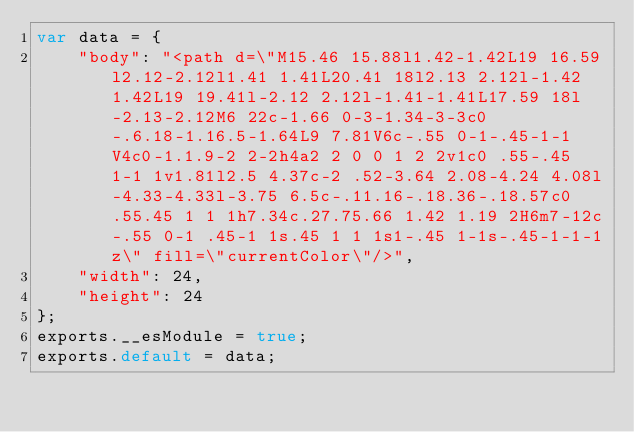<code> <loc_0><loc_0><loc_500><loc_500><_JavaScript_>var data = {
	"body": "<path d=\"M15.46 15.88l1.42-1.42L19 16.59l2.12-2.12l1.41 1.41L20.41 18l2.13 2.12l-1.42 1.42L19 19.41l-2.12 2.12l-1.41-1.41L17.59 18l-2.13-2.12M6 22c-1.66 0-3-1.34-3-3c0-.6.18-1.16.5-1.64L9 7.81V6c-.55 0-1-.45-1-1V4c0-1.1.9-2 2-2h4a2 2 0 0 1 2 2v1c0 .55-.45 1-1 1v1.81l2.5 4.37c-2 .52-3.64 2.08-4.24 4.08l-4.33-4.33l-3.75 6.5c-.11.16-.18.36-.18.57c0 .55.45 1 1 1h7.34c.27.75.66 1.42 1.19 2H6m7-12c-.55 0-1 .45-1 1s.45 1 1 1s1-.45 1-1s-.45-1-1-1z\" fill=\"currentColor\"/>",
	"width": 24,
	"height": 24
};
exports.__esModule = true;
exports.default = data;
</code> 